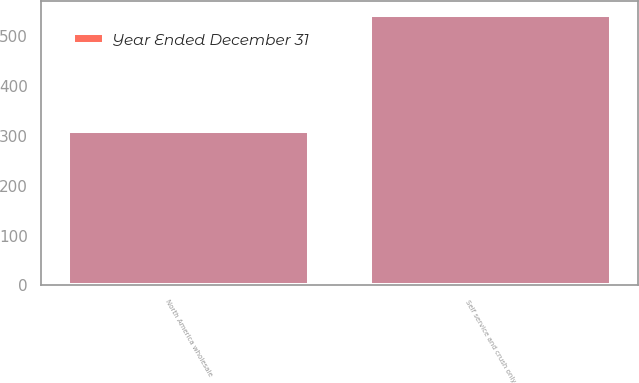Convert chart to OTSL. <chart><loc_0><loc_0><loc_500><loc_500><stacked_bar_chart><ecel><fcel>North America wholesale<fcel>Self service and crush only<nl><fcel>nan<fcel>310<fcel>542<nl><fcel>Year Ended December 31<fcel>1<fcel>2<nl></chart> 